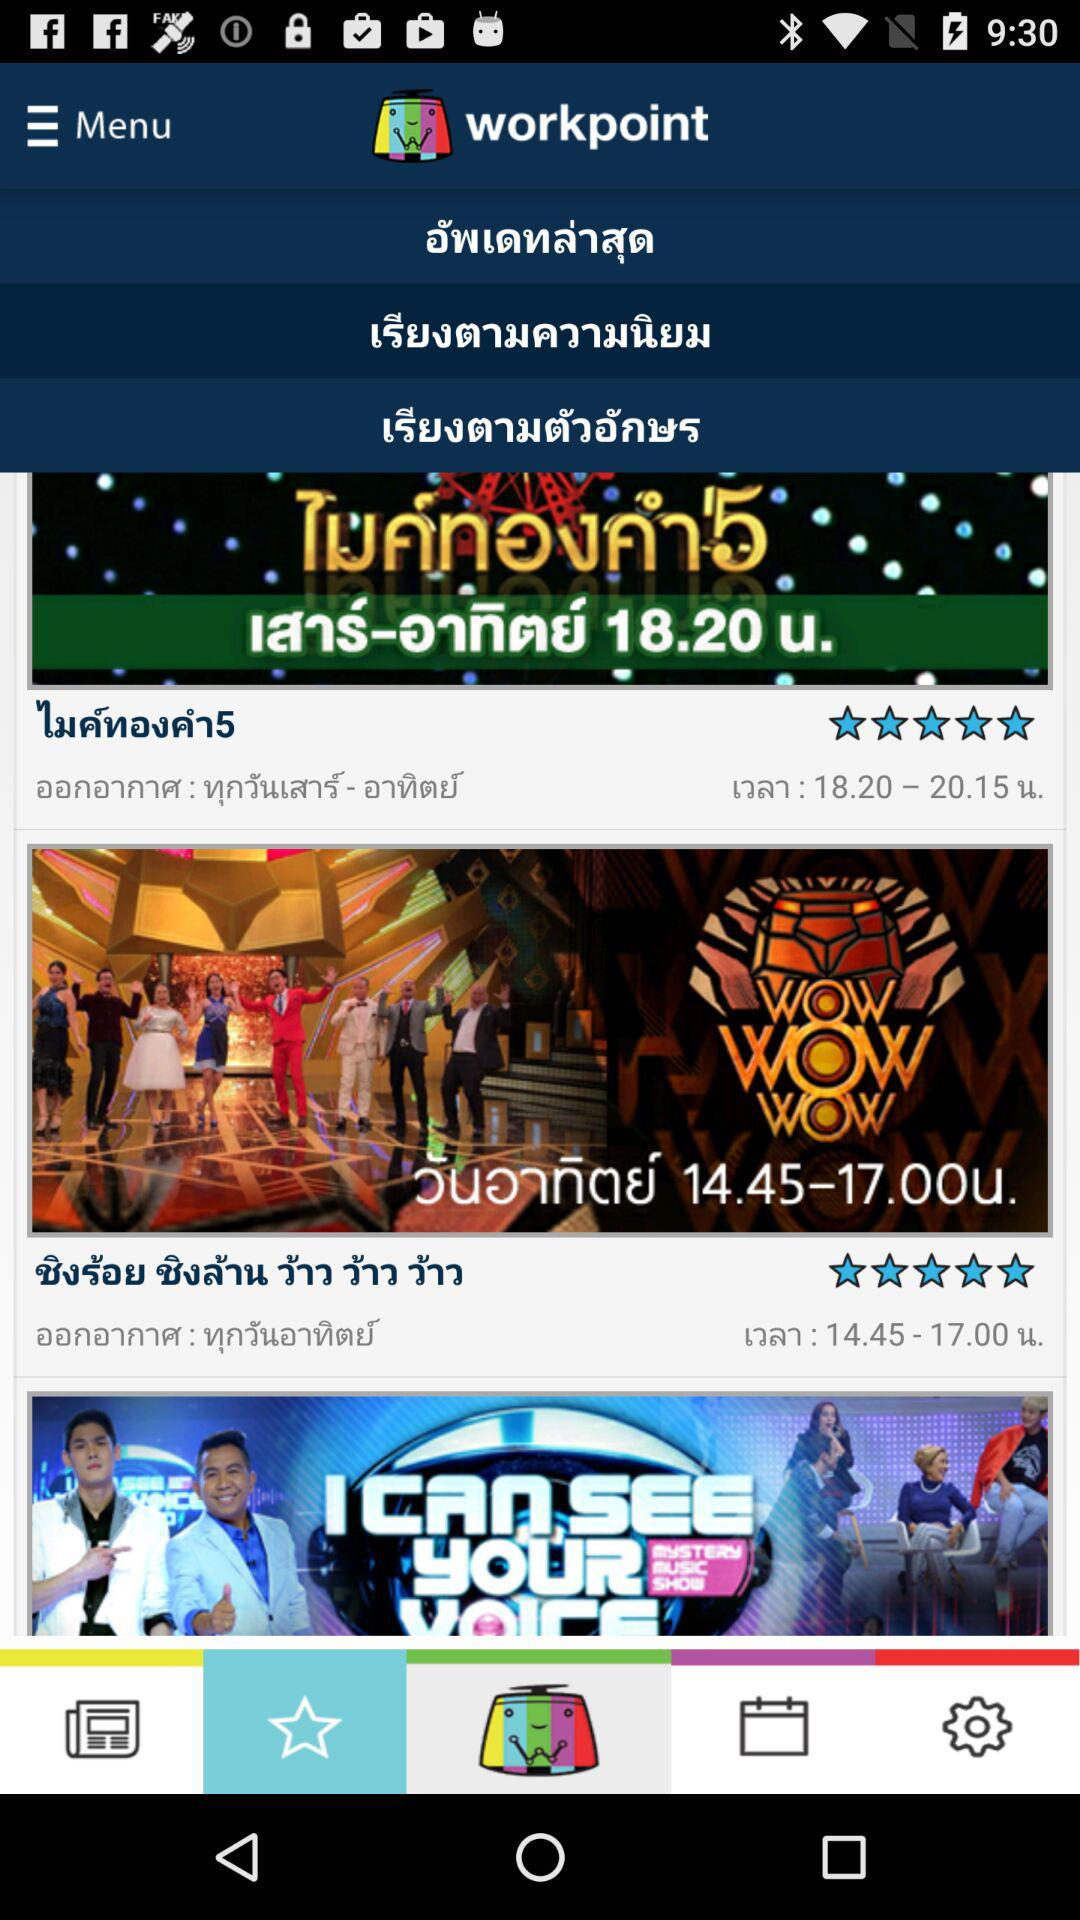What is the name of the application? The name of the application is "workpoint". 